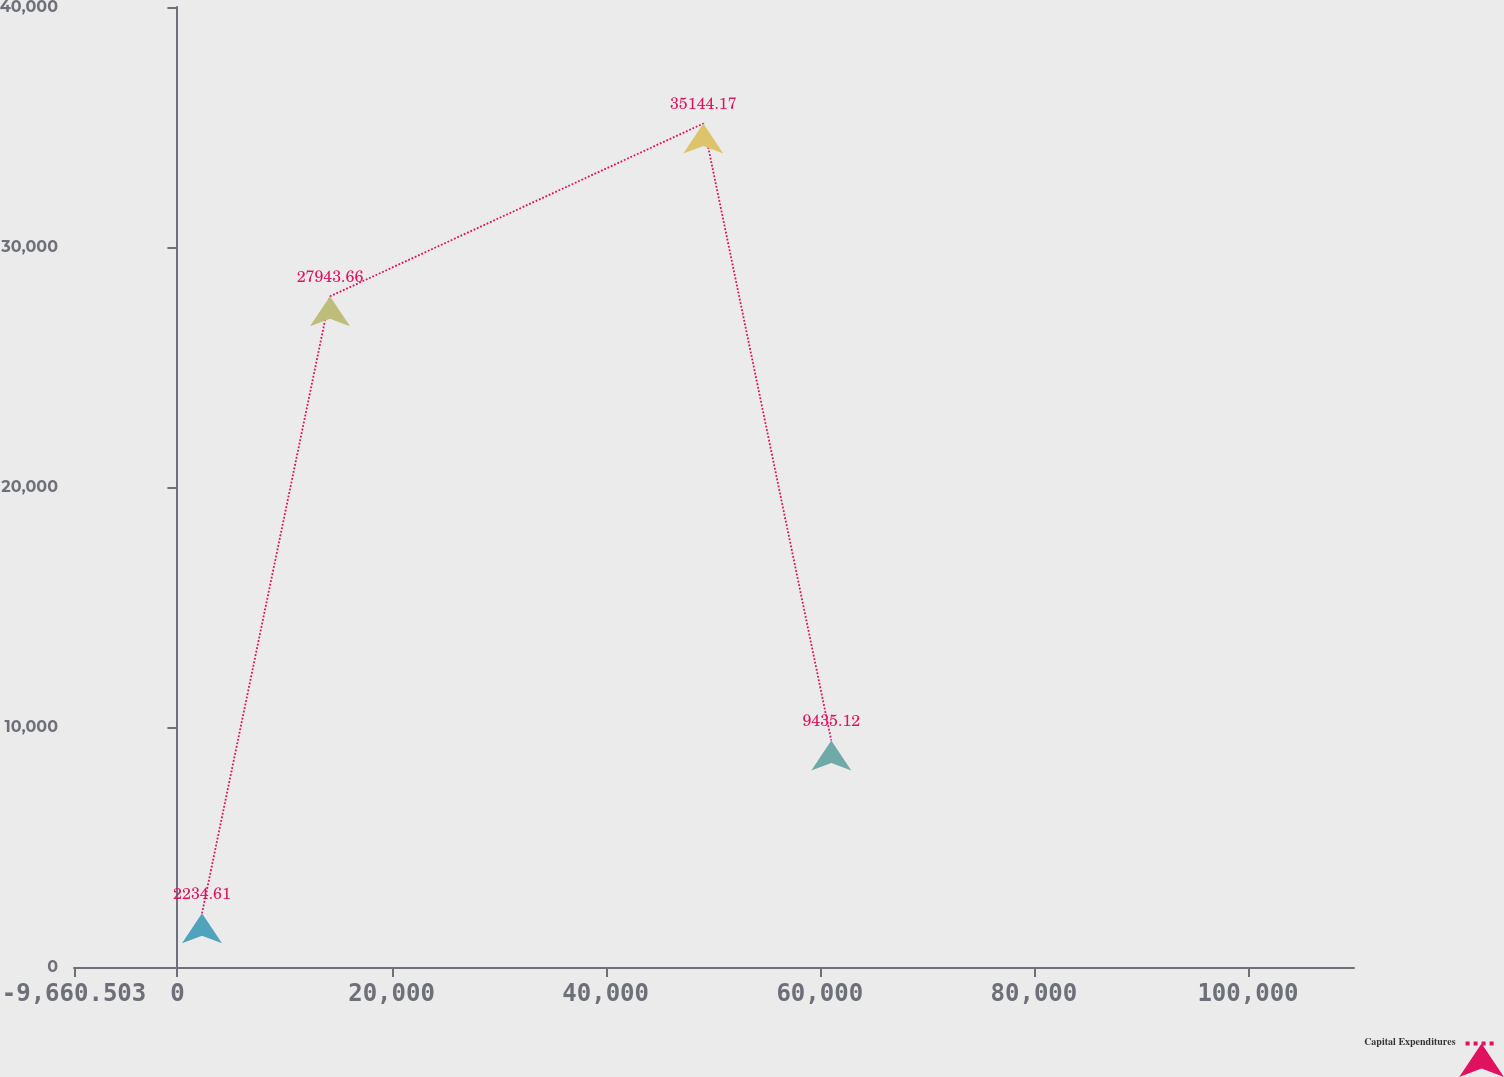Convert chart. <chart><loc_0><loc_0><loc_500><loc_500><line_chart><ecel><fcel>Capital Expenditures<nl><fcel>2295.75<fcel>2234.61<nl><fcel>14252<fcel>27943.7<nl><fcel>49121.2<fcel>35144.2<nl><fcel>61077.4<fcel>9435.12<nl><fcel>121858<fcel>74239.7<nl></chart> 